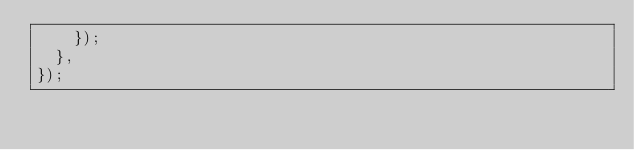<code> <loc_0><loc_0><loc_500><loc_500><_JavaScript_>    });
  },
});
</code> 